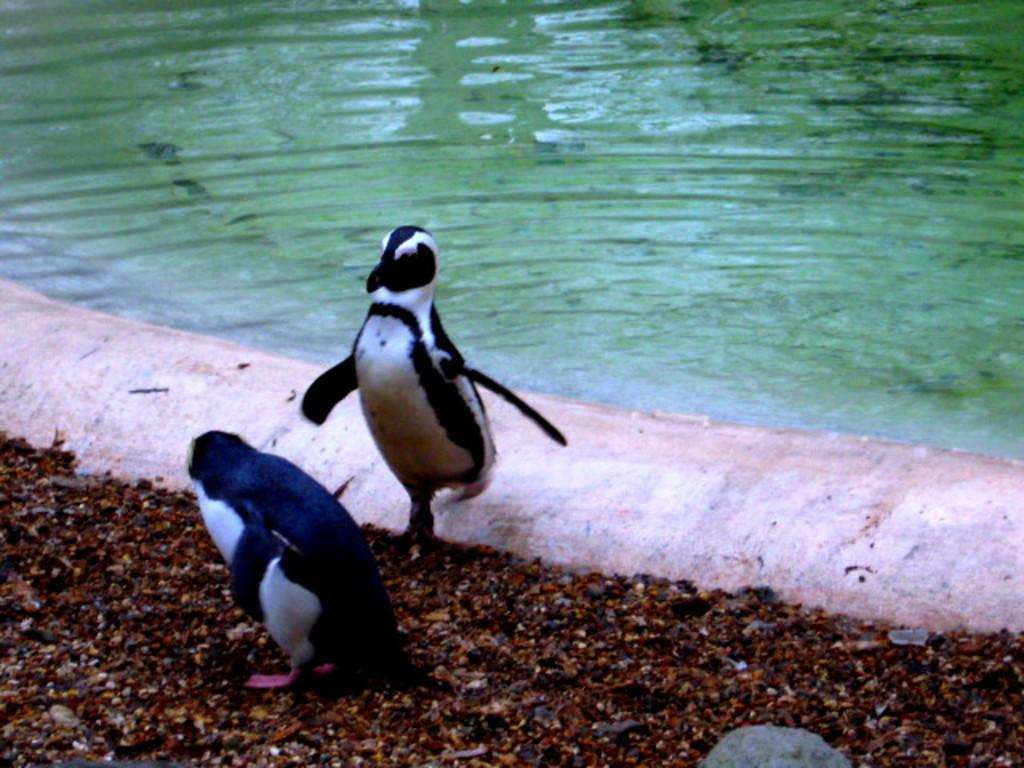What type of animals can be seen on the ground in the image? There are penguins on the ground in the image. What natural element is visible in the image? There is water visible in the image. What type of terrain is present in the image? There is a snowy area in the image. Can you describe the observation made by the penguin's tongue in the image? There is no indication of a penguin's tongue making an observation in the image, as penguins do not have the ability to make observations with their tongues. 